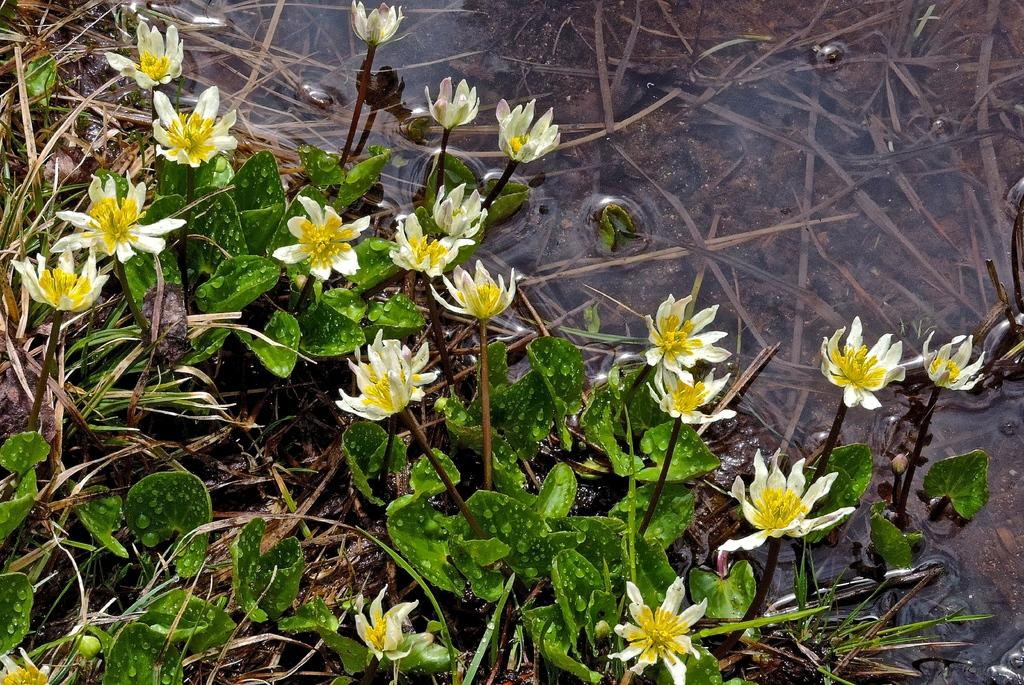What is located in the foreground of the image? There are flowers in the foreground of the image. What type of living organisms are associated with the flowers? The flowers are associated with plants. What natural element can be seen in the image? There is water visible in the image. What type of vegetation is visible in the image? There is grass visible in the image. What type of hand can be seen holding the flowers in the image? There is no hand visible in the image; it only shows flowers, plants, water, and grass. 